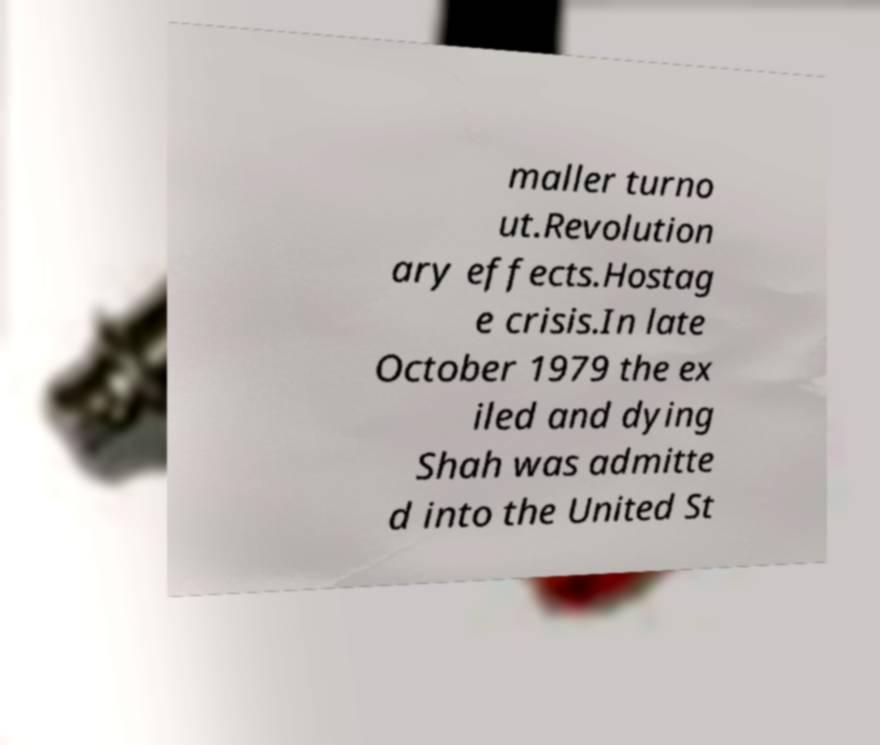Could you assist in decoding the text presented in this image and type it out clearly? maller turno ut.Revolution ary effects.Hostag e crisis.In late October 1979 the ex iled and dying Shah was admitte d into the United St 